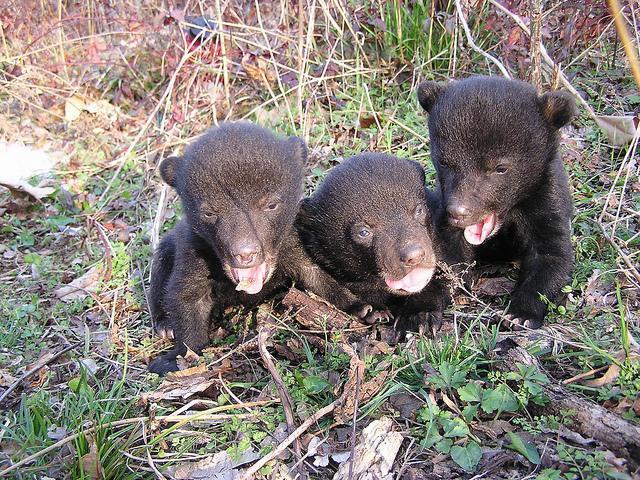How many bears are in the picture?
Give a very brief answer. 3. 